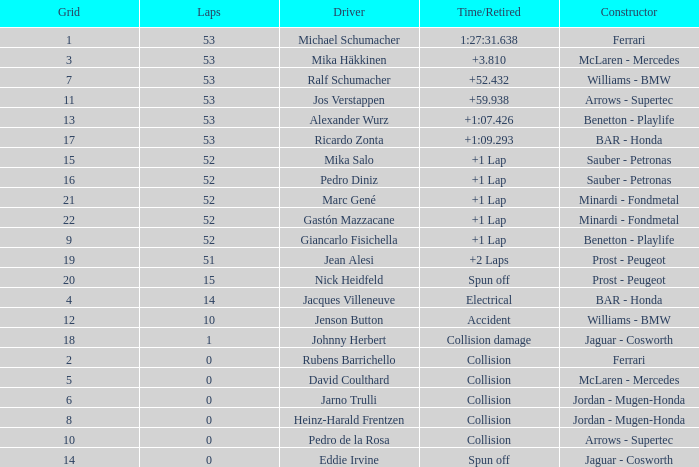What is the grid number with less than 52 laps and a Time/Retired of collision, and a Constructor of arrows - supertec? 1.0. 